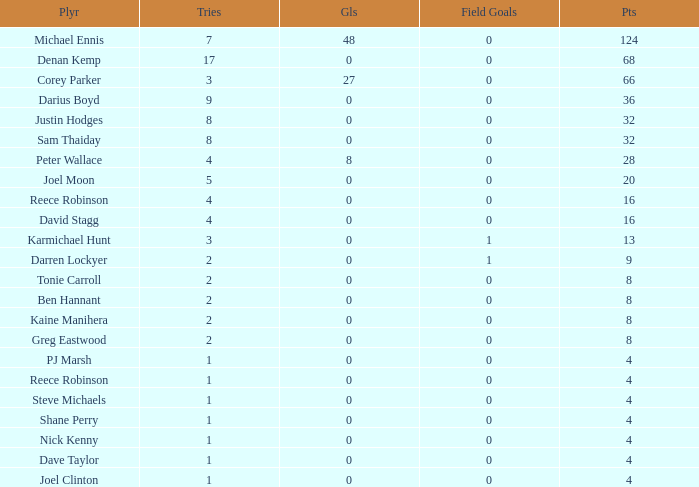What is the number of goals Dave Taylor, who has more than 1 tries, has? None. 